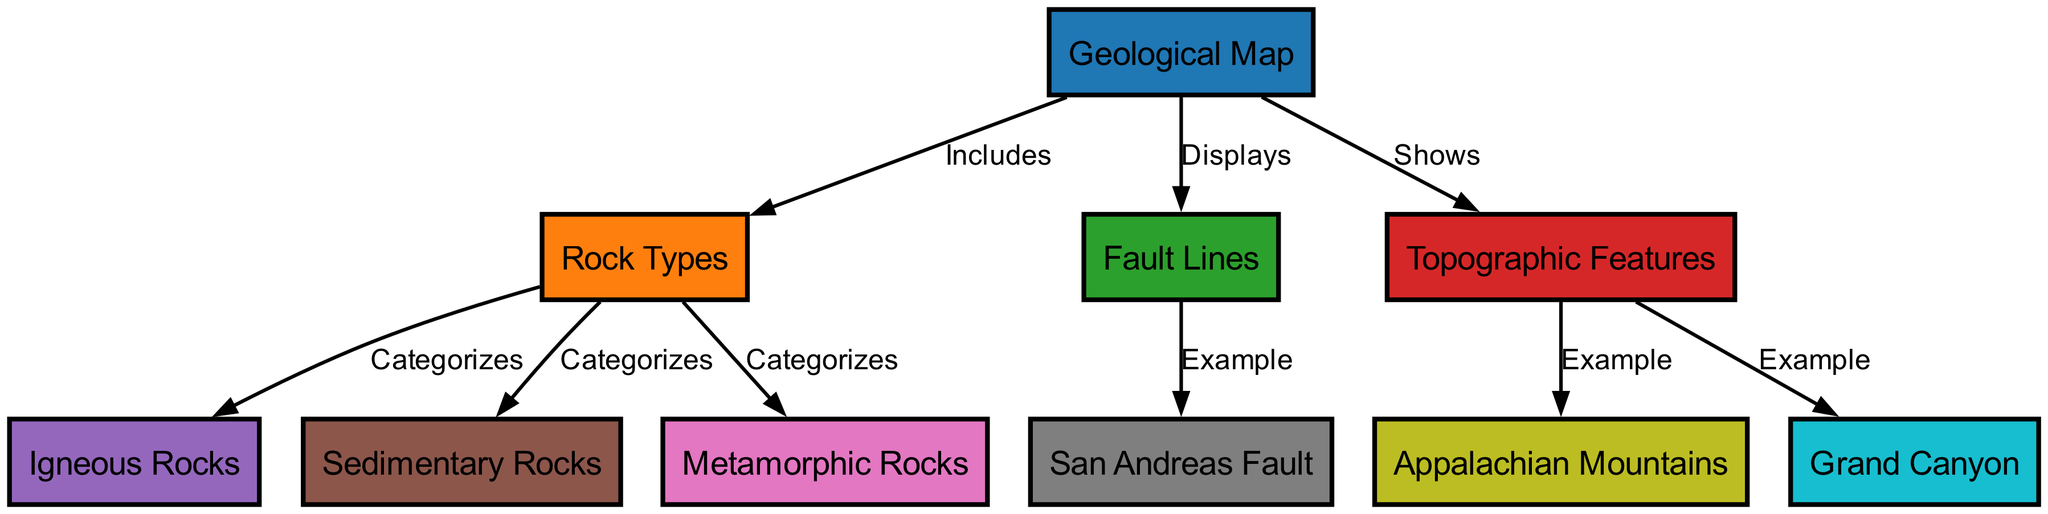What are the three categories of rock types shown in the diagram? The diagram includes three categories for rock types: Igneous Rocks, Sedimentary Rocks, and Metamorphic Rocks. These can be identified under the "Rock Types" node and its connections.
Answer: Igneous Rocks, Sedimentary Rocks, Metamorphic Rocks How many edges are there connecting the nodes in the diagram? To find the number of edges, we count all the connections in the diagram's edges section. There are a total of eight edges listed.
Answer: 8 Which fault line is highlighted as an example in the diagram? Looking at the edges of the "Fault Lines" node, the diagram specifies the San Andreas Fault as an example. This is explicitly mentioned in the edge connection from "Fault Lines" to "San Andreas Fault".
Answer: San Andreas Fault What type of geological feature is the Grand Canyon classified as? The Grand Canyon falls under the "Topographic Features" category, as indicated by the edge connecting "Topographic Features" to "Grand Canyon".
Answer: Topographic Feature Which category does each of the rock types belong to in this graphical representation? The diagram shows that Igneous Rocks, Sedimentary Rocks, and Metamorphic Rocks are categorized under the "Rock Types" node. The connections illustrate which rock types are included in this category.
Answer: Rock Types In the geological map, which major mountain range is used as an example of a topographic feature? The Appalachian Mountains are labeled as an example of a topographic feature in the diagram, as shown by the edge that connects "Topographic Features" to "Appalachian Mountains".
Answer: Appalachian Mountains How many categories of rock types are represented in the diagram? The categories represented in the diagram are three: Igneous, Sedimentary, and Metamorphic. This is based on the connections from the "Rock Types" node.
Answer: 3 Which element does the geological map "Shows"? The geological map "Shows" topographic features, as indicated by the directed edge between the "Geological Map" node and the "Topographic Features" node in the diagram.
Answer: Topographic Features 